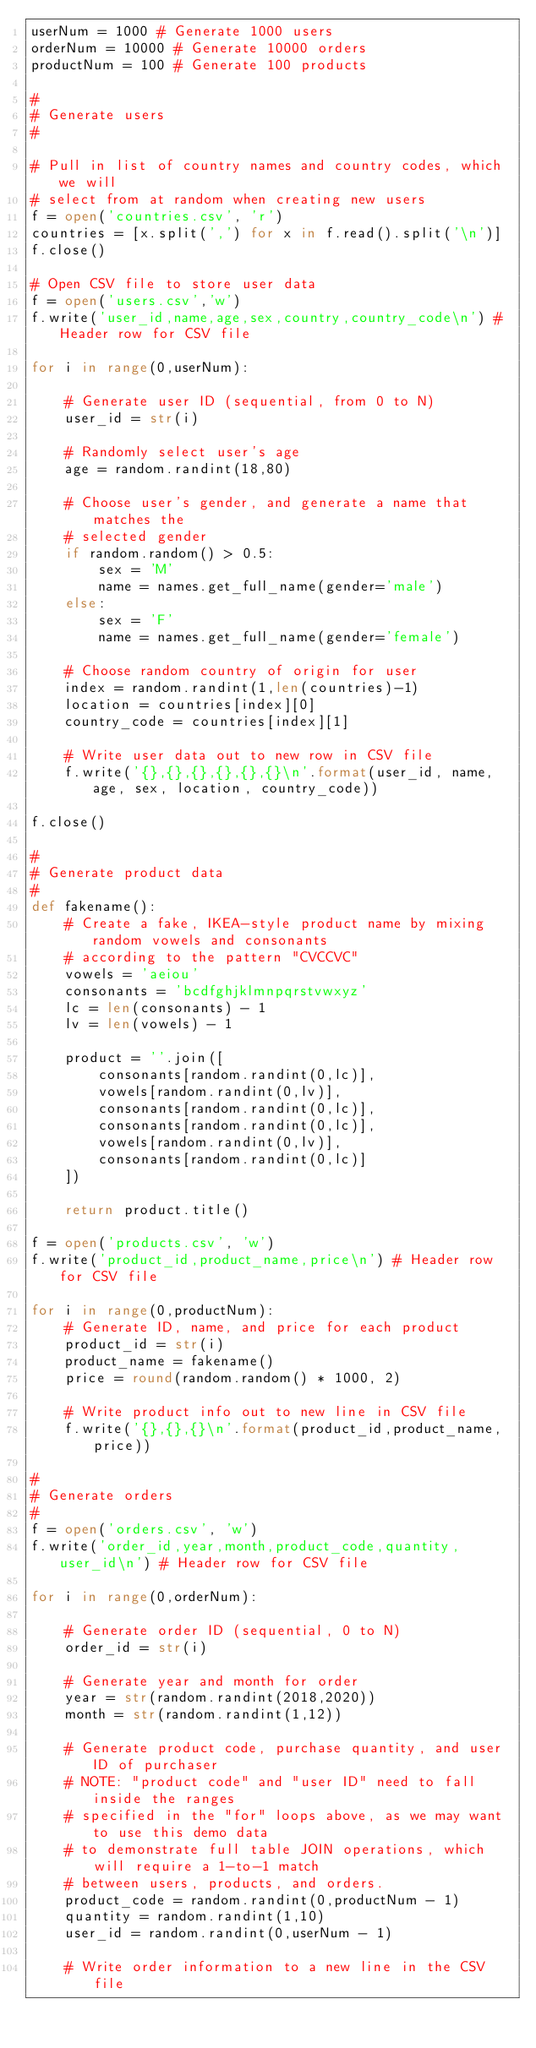Convert code to text. <code><loc_0><loc_0><loc_500><loc_500><_Python_>userNum = 1000 # Generate 1000 users
orderNum = 10000 # Generate 10000 orders
productNum = 100 # Generate 100 products

#
# Generate users
#

# Pull in list of country names and country codes, which we will
# select from at random when creating new users
f = open('countries.csv', 'r')
countries = [x.split(',') for x in f.read().split('\n')]
f.close()

# Open CSV file to store user data
f = open('users.csv','w')
f.write('user_id,name,age,sex,country,country_code\n') # Header row for CSV file

for i in range(0,userNum):

    # Generate user ID (sequential, from 0 to N)
    user_id = str(i)

    # Randomly select user's age
    age = random.randint(18,80)
    
    # Choose user's gender, and generate a name that matches the 
    # selected gender
    if random.random() > 0.5:
        sex = 'M'
        name = names.get_full_name(gender='male')
    else:
        sex = 'F'
        name = names.get_full_name(gender='female')

    # Choose random country of origin for user
    index = random.randint(1,len(countries)-1)
    location = countries[index][0]
    country_code = countries[index][1]

    # Write user data out to new row in CSV file
    f.write('{},{},{},{},{},{}\n'.format(user_id, name, age, sex, location, country_code))

f.close()

#
# Generate product data
#
def fakename():
    # Create a fake, IKEA-style product name by mixing random vowels and consonants
    # according to the pattern "CVCCVC"
    vowels = 'aeiou'
    consonants = 'bcdfghjklmnpqrstvwxyz'
    lc = len(consonants) - 1
    lv = len(vowels) - 1

    product = ''.join([
        consonants[random.randint(0,lc)],
        vowels[random.randint(0,lv)],
        consonants[random.randint(0,lc)],
        consonants[random.randint(0,lc)],
        vowels[random.randint(0,lv)],
        consonants[random.randint(0,lc)]
    ])

    return product.title()

f = open('products.csv', 'w') 
f.write('product_id,product_name,price\n') # Header row for CSV file

for i in range(0,productNum):
    # Generate ID, name, and price for each product
    product_id = str(i)
    product_name = fakename()
    price = round(random.random() * 1000, 2)

    # Write product info out to new line in CSV file
    f.write('{},{},{}\n'.format(product_id,product_name,price))

#
# Generate orders
#
f = open('orders.csv', 'w')
f.write('order_id,year,month,product_code,quantity,user_id\n') # Header row for CSV file

for i in range(0,orderNum):

    # Generate order ID (sequential, 0 to N)
    order_id = str(i)

    # Generate year and month for order
    year = str(random.randint(2018,2020))
    month = str(random.randint(1,12))

    # Generate product code, purchase quantity, and user ID of purchaser
    # NOTE: "product code" and "user ID" need to fall inside the ranges
    # specified in the "for" loops above, as we may want to use this demo data
    # to demonstrate full table JOIN operations, which will require a 1-to-1 match
    # between users, products, and orders. 
    product_code = random.randint(0,productNum - 1)
    quantity = random.randint(1,10)
    user_id = random.randint(0,userNum - 1)

    # Write order information to a new line in the CSV file</code> 